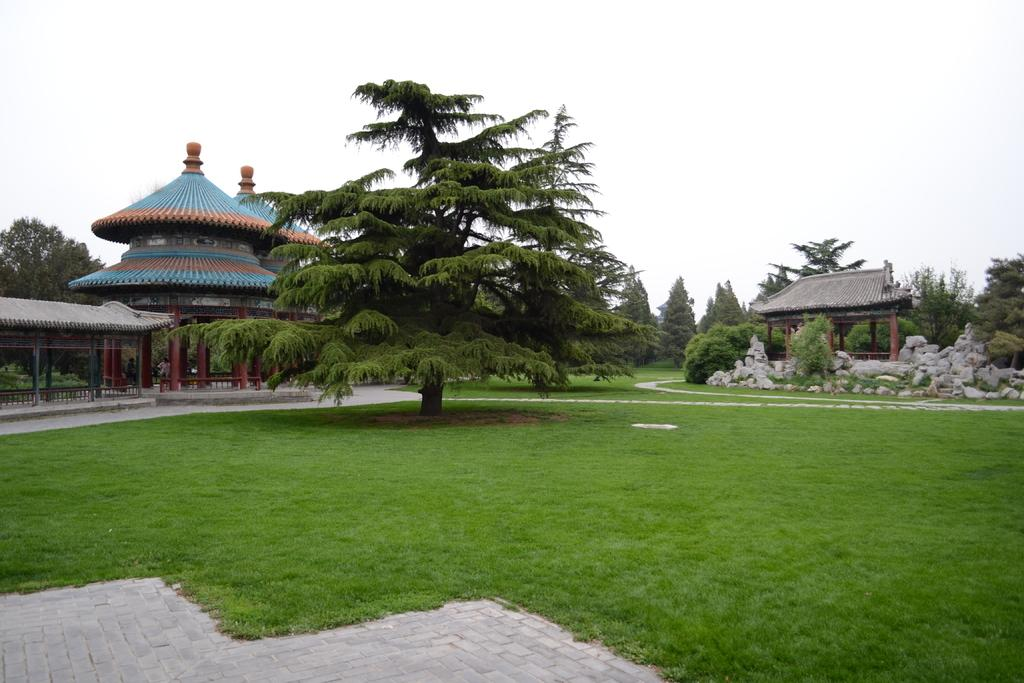What type of vegetation is present on the grass land in the image? There are many trees on the grass land in the image. What structure can be seen on the right side of the image? There is a shed on the right side of the image. What type of building is located on the left side of the image? There is a temple on the left side of the image. What is visible above the temple and shed in the image? The sky is visible above the temple and shed in the image. How many clovers are growing on the grass land in the image? There is no mention of clovers in the image, so we cannot determine the number of clovers present. What is the caption of the image? There is no caption provided for the image, so we cannot determine the caption. 